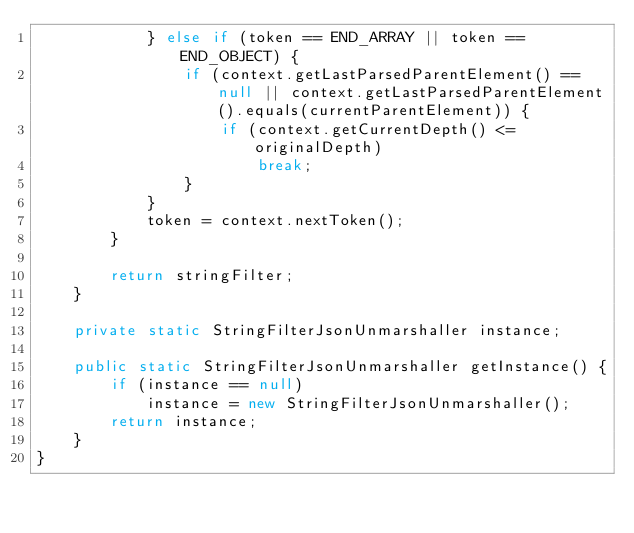<code> <loc_0><loc_0><loc_500><loc_500><_Java_>            } else if (token == END_ARRAY || token == END_OBJECT) {
                if (context.getLastParsedParentElement() == null || context.getLastParsedParentElement().equals(currentParentElement)) {
                    if (context.getCurrentDepth() <= originalDepth)
                        break;
                }
            }
            token = context.nextToken();
        }

        return stringFilter;
    }

    private static StringFilterJsonUnmarshaller instance;

    public static StringFilterJsonUnmarshaller getInstance() {
        if (instance == null)
            instance = new StringFilterJsonUnmarshaller();
        return instance;
    }
}
</code> 